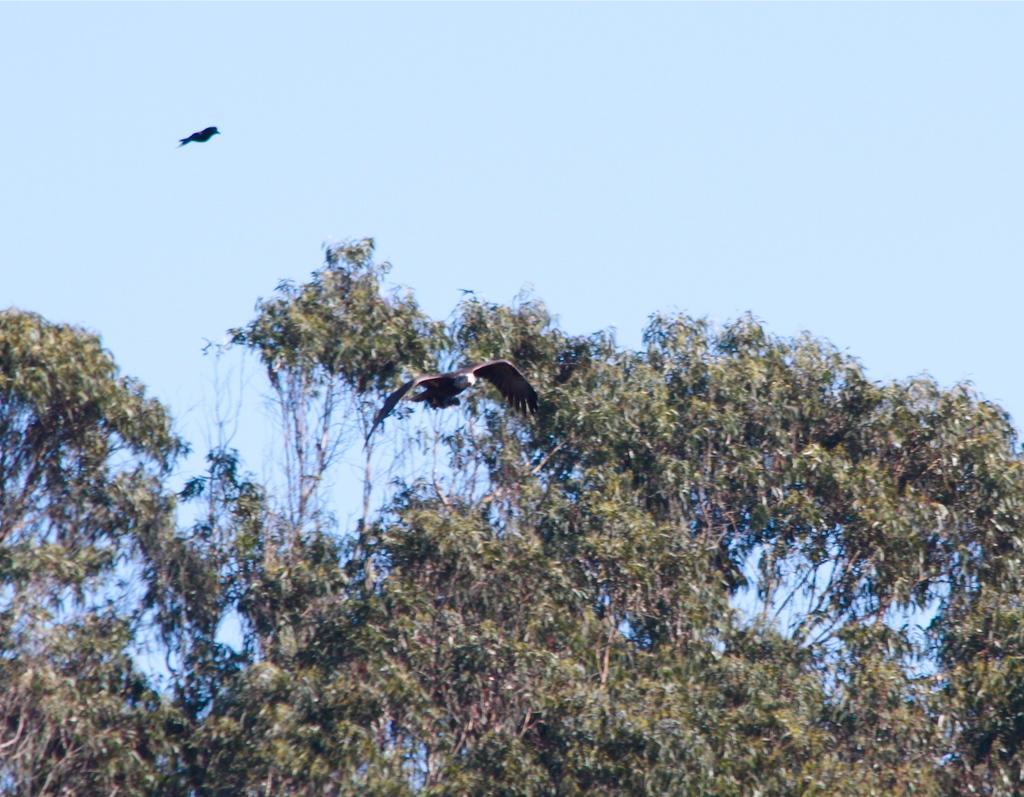In one or two sentences, can you explain what this image depicts? In the image there are two birds flying in the air, in the background there is a tree and above its sky. 